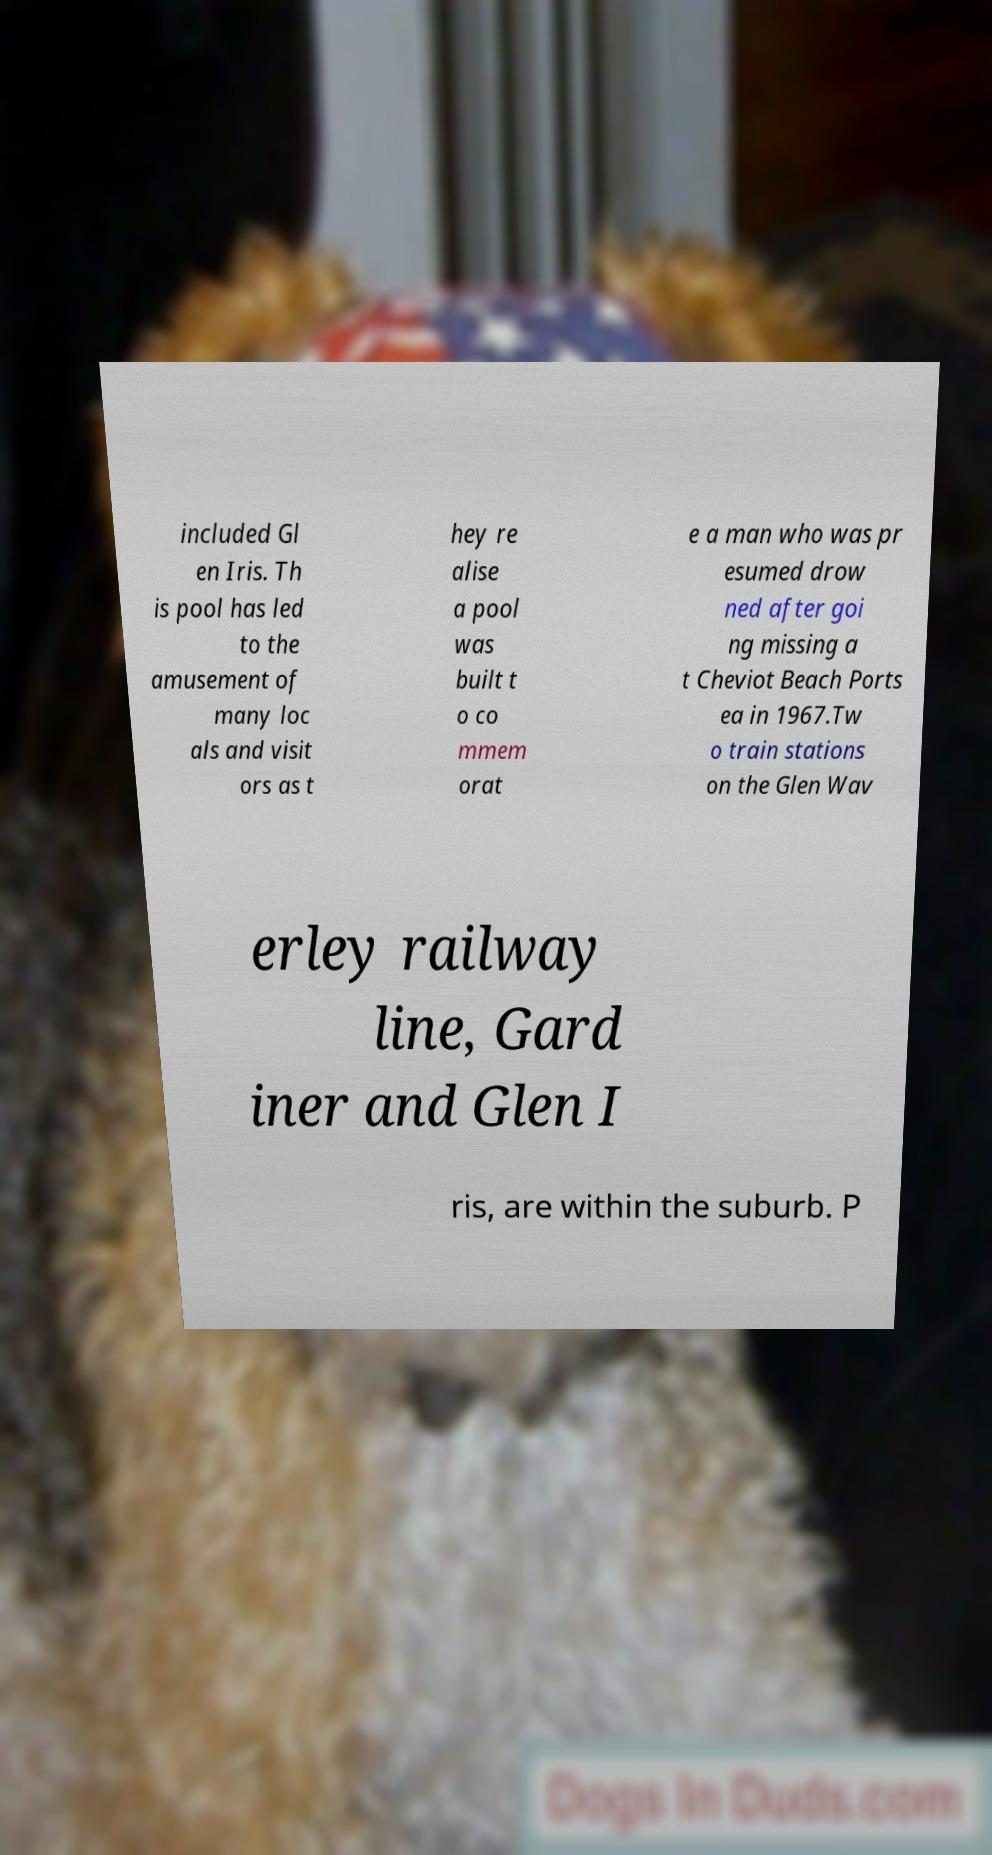Could you assist in decoding the text presented in this image and type it out clearly? included Gl en Iris. Th is pool has led to the amusement of many loc als and visit ors as t hey re alise a pool was built t o co mmem orat e a man who was pr esumed drow ned after goi ng missing a t Cheviot Beach Ports ea in 1967.Tw o train stations on the Glen Wav erley railway line, Gard iner and Glen I ris, are within the suburb. P 